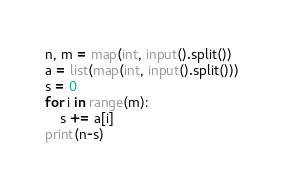Convert code to text. <code><loc_0><loc_0><loc_500><loc_500><_Python_>n, m = map(int, input().split())
a = list(map(int, input().split()))
s = 0
for i in range(m):
    s += a[i]
print(n-s)</code> 